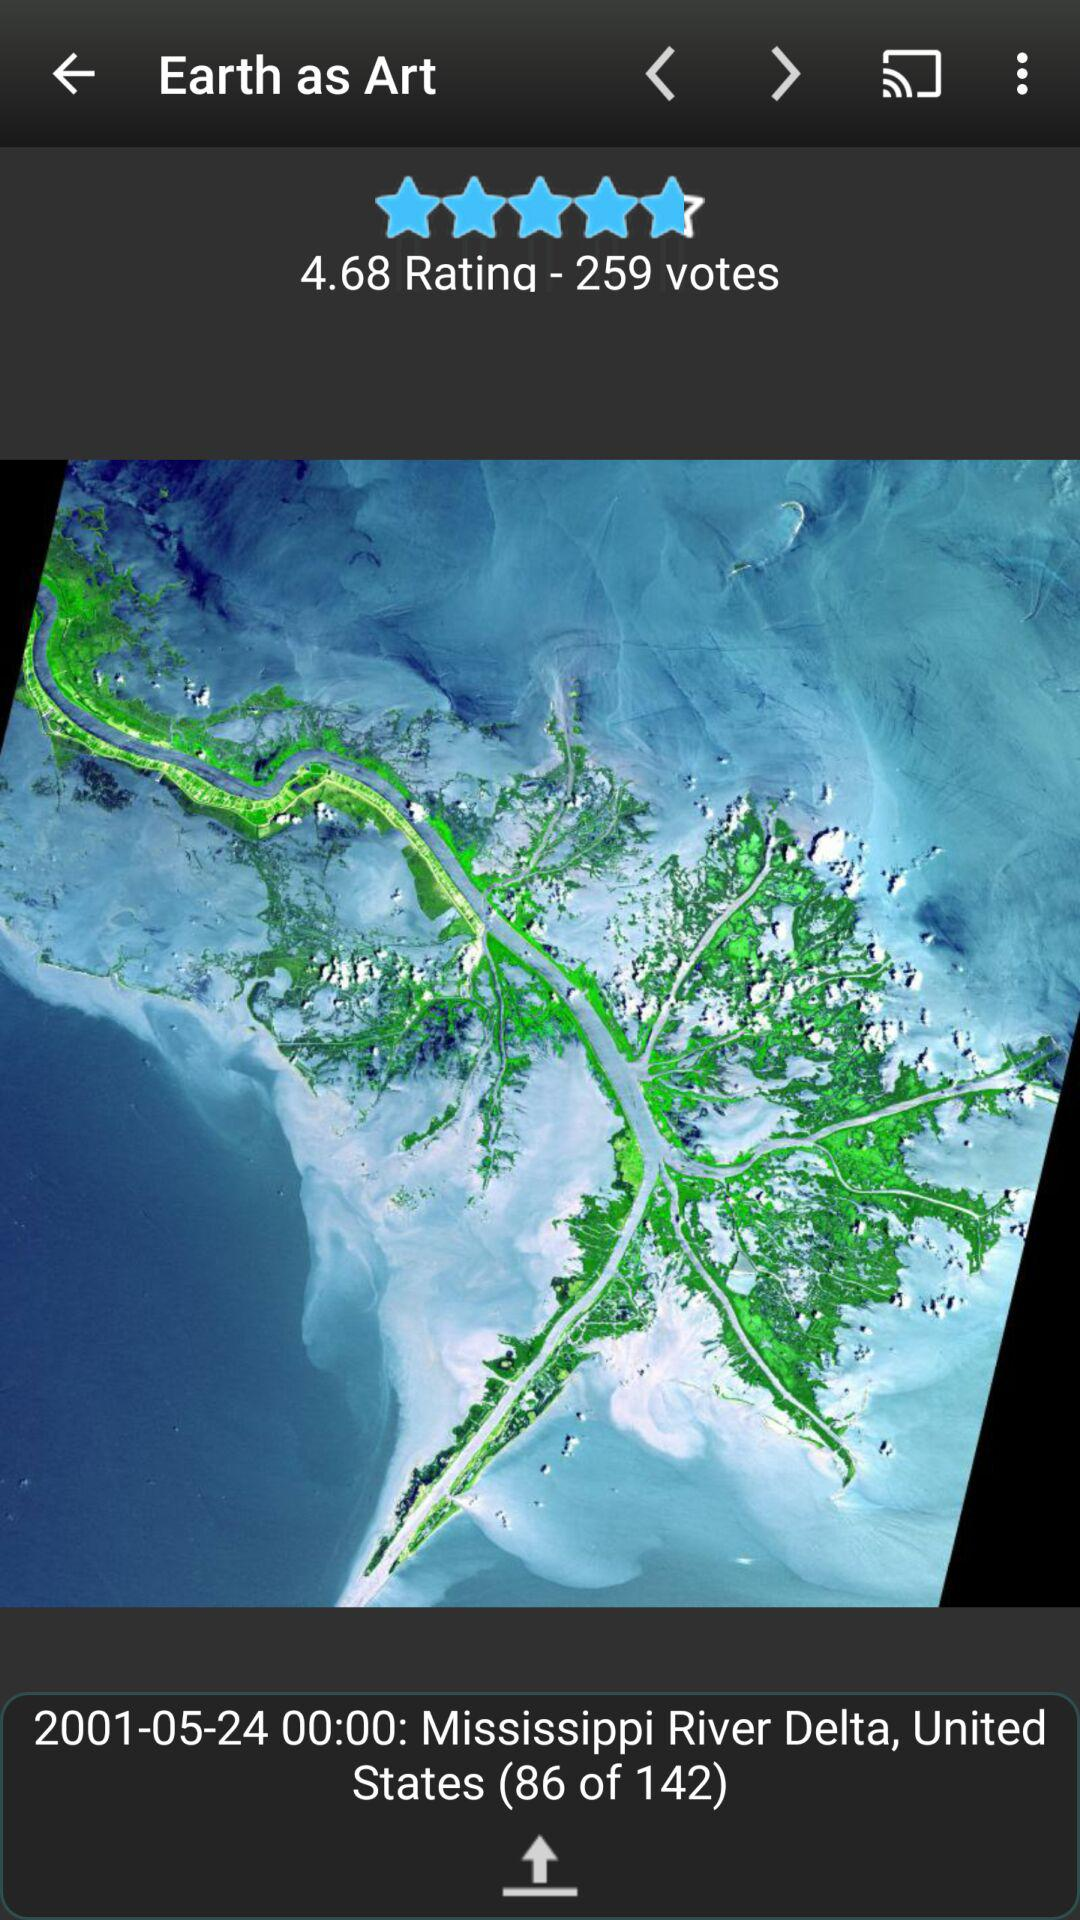What is the total number of states?
When the provided information is insufficient, respond with <no answer>. <no answer> 